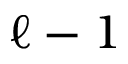Convert formula to latex. <formula><loc_0><loc_0><loc_500><loc_500>{ \ell - 1 }</formula> 